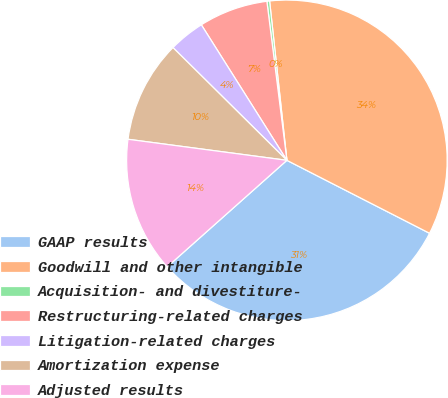Convert chart to OTSL. <chart><loc_0><loc_0><loc_500><loc_500><pie_chart><fcel>GAAP results<fcel>Goodwill and other intangible<fcel>Acquisition- and divestiture-<fcel>Restructuring-related charges<fcel>Litigation-related charges<fcel>Amortization expense<fcel>Adjusted results<nl><fcel>30.9%<fcel>34.24%<fcel>0.27%<fcel>6.97%<fcel>3.62%<fcel>10.32%<fcel>13.67%<nl></chart> 